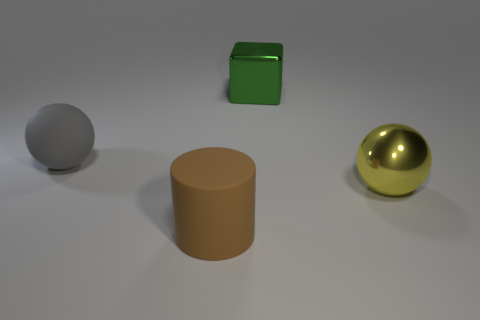Add 4 small red metal cubes. How many objects exist? 8 Subtract all cubes. How many objects are left? 3 Subtract all big brown cylinders. Subtract all gray things. How many objects are left? 2 Add 4 yellow metallic spheres. How many yellow metallic spheres are left? 5 Add 2 small brown metal things. How many small brown metal things exist? 2 Subtract 1 green blocks. How many objects are left? 3 